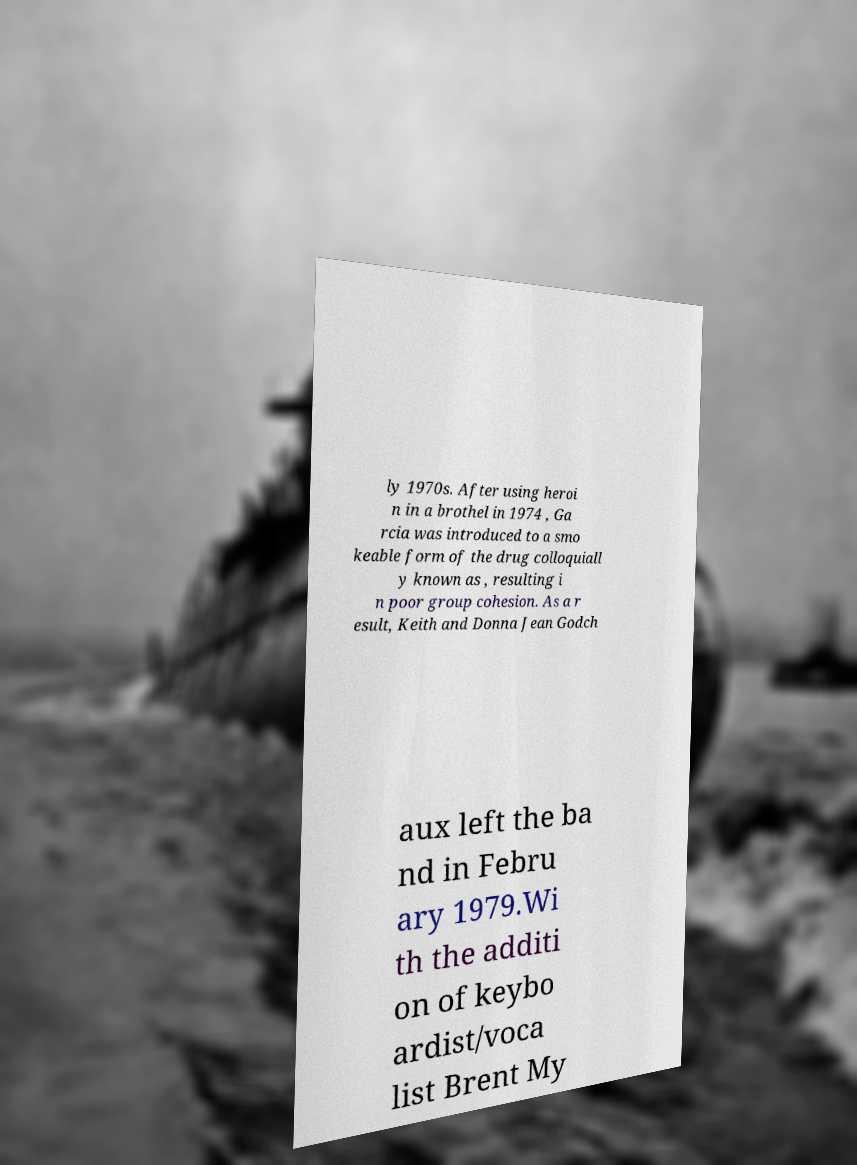Can you accurately transcribe the text from the provided image for me? ly 1970s. After using heroi n in a brothel in 1974 , Ga rcia was introduced to a smo keable form of the drug colloquiall y known as , resulting i n poor group cohesion. As a r esult, Keith and Donna Jean Godch aux left the ba nd in Febru ary 1979.Wi th the additi on of keybo ardist/voca list Brent My 